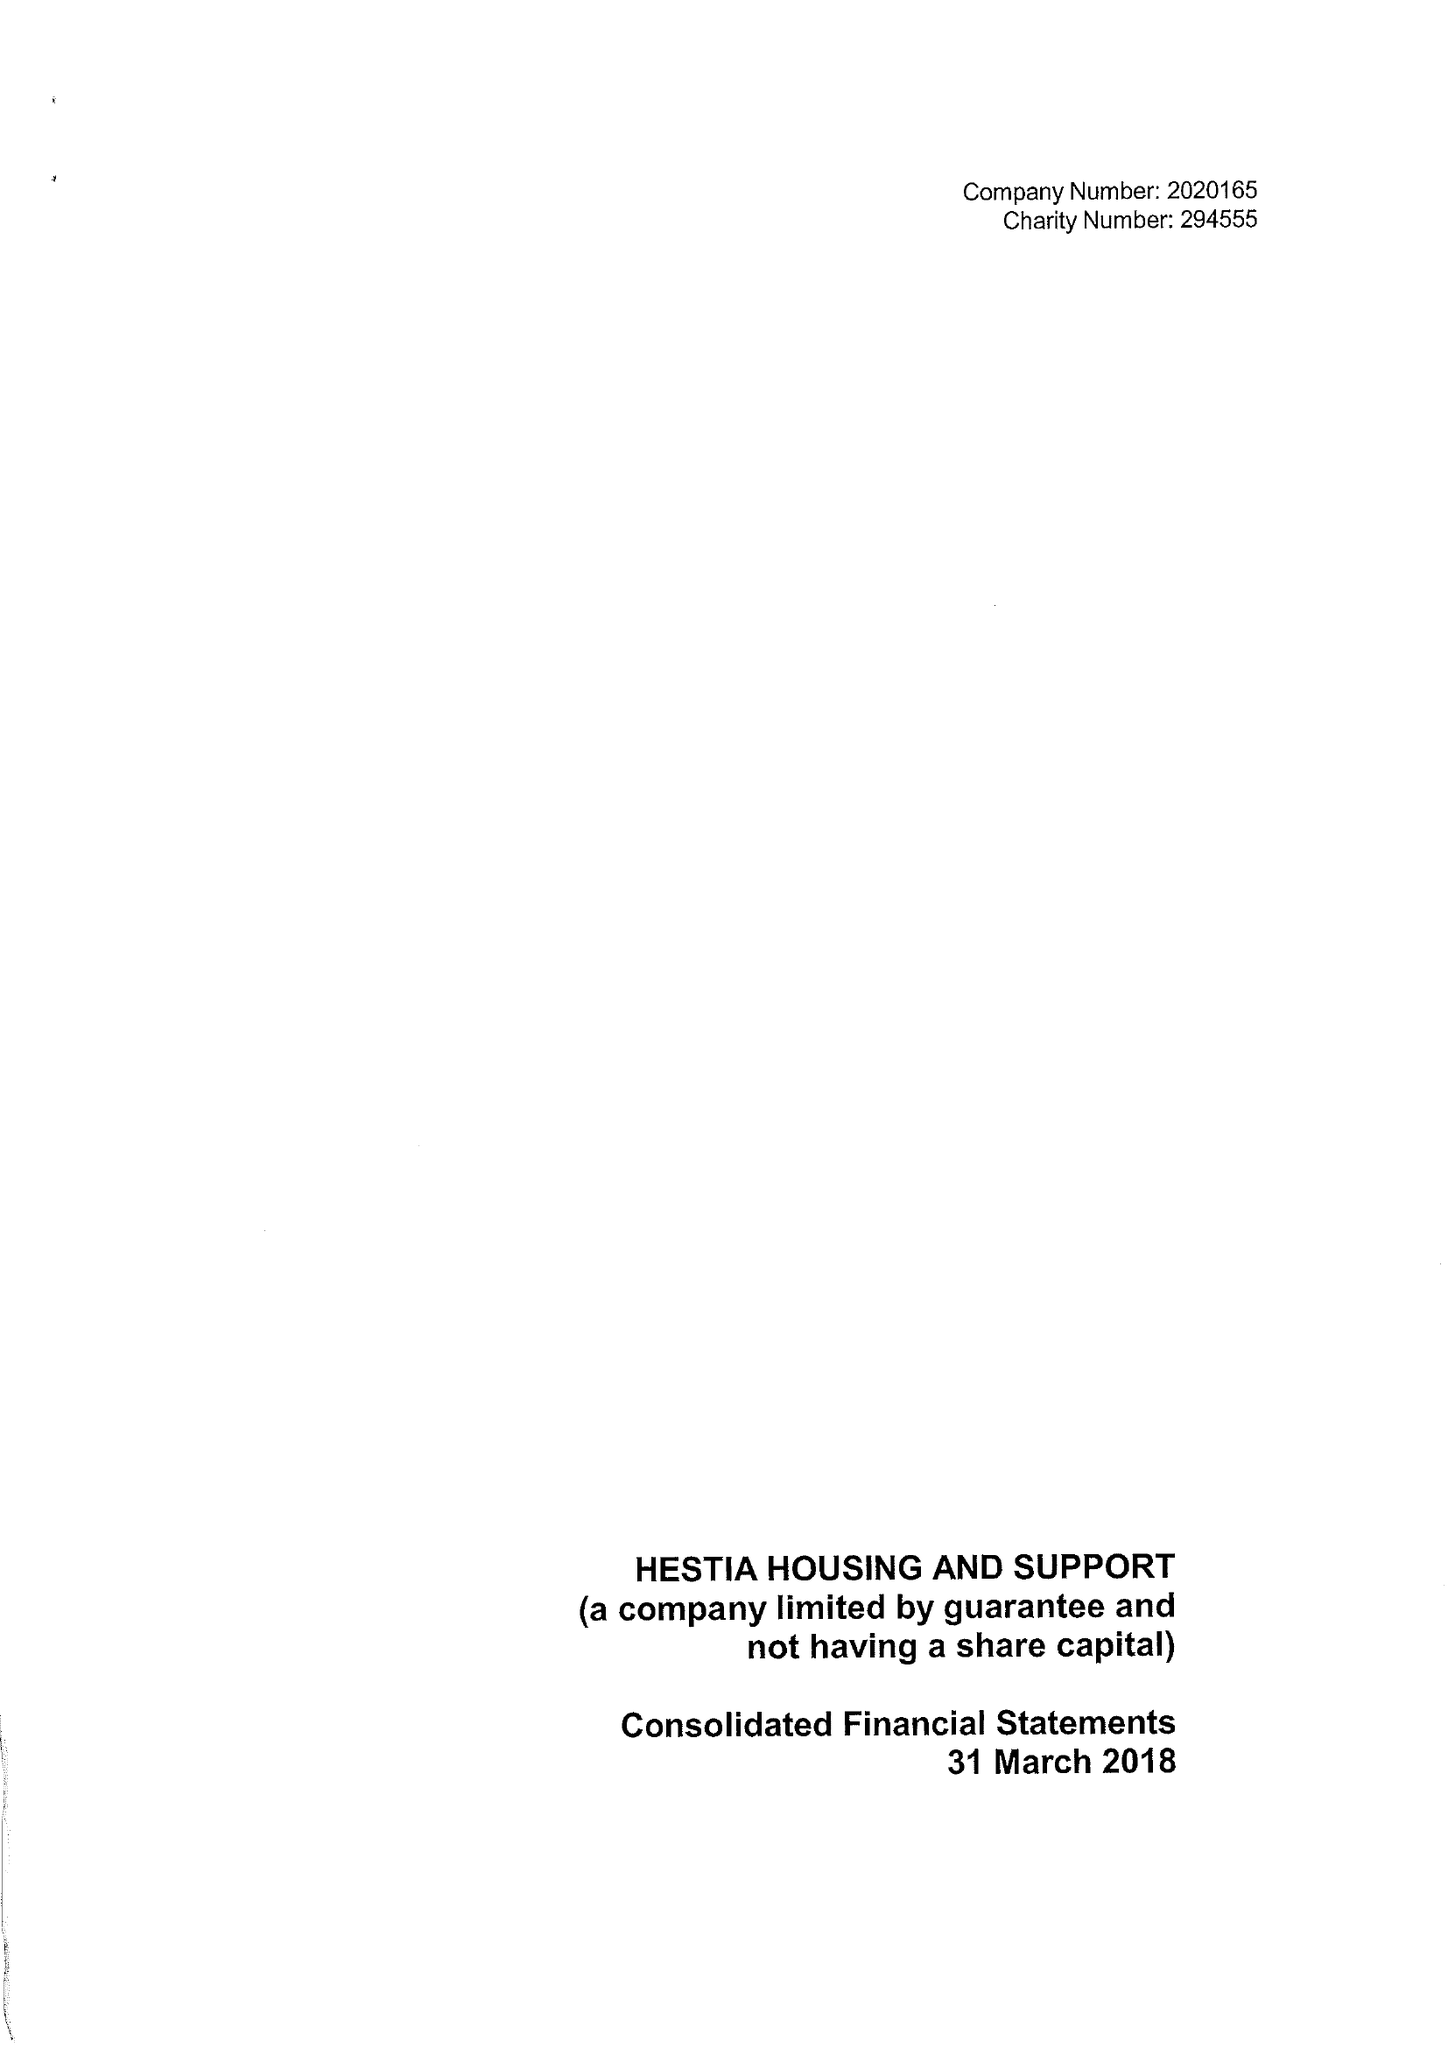What is the value for the address__postcode?
Answer the question using a single word or phrase. SE1 1LB 